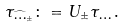Convert formula to latex. <formula><loc_0><loc_0><loc_500><loc_500>\tau _ { \widehat { \mathbf \Phi } _ { \pm } } \colon = U _ { \pm } \tau _ { \mathbf \Phi } \, .</formula> 